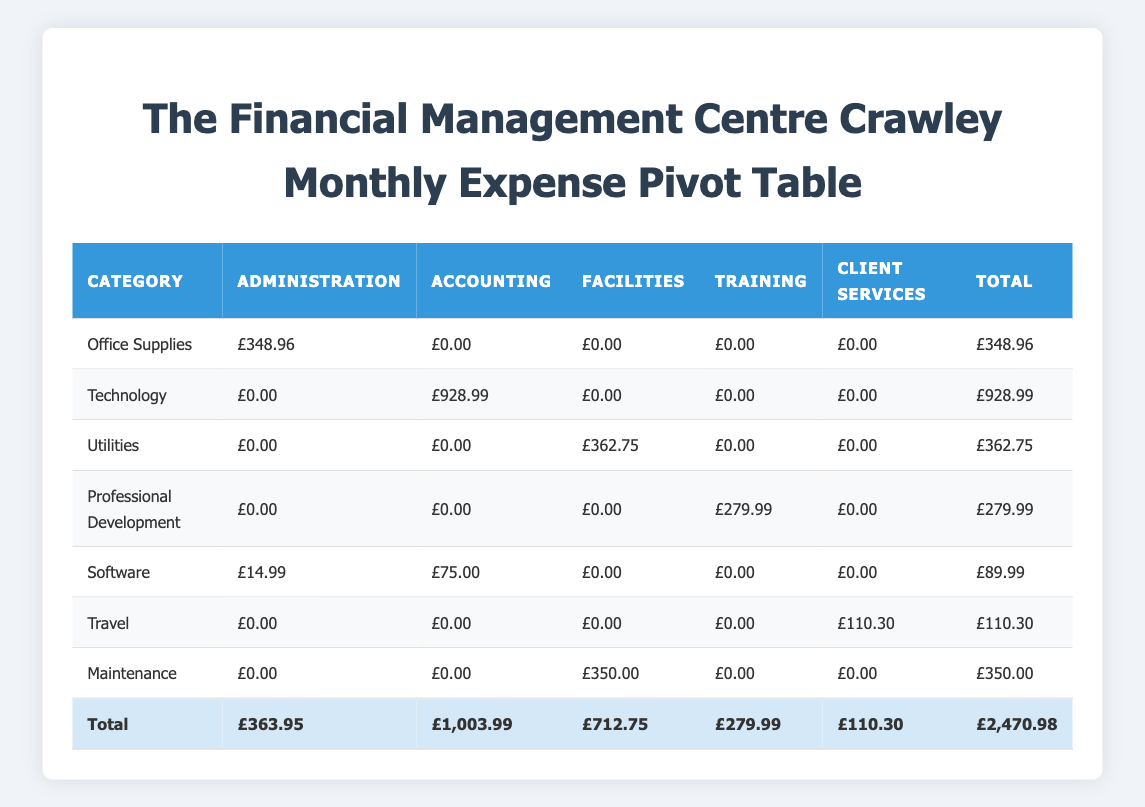What is the total expenditure for the Administration department? By looking at the row for Administration, we can sum its expenses across all categories. The values are £348.96 (Office Supplies), £14.99 (Software), and £0.00 for the other categories. Adding these gives £348.96 + £14.99 = £363.95.
Answer: £363.95 Which department has the highest total expenditure? To find the department with the highest total, we need to look at the total column at the bottom of each department's column. The values are: Administration £363.95, Accounting £1,003.99, Facilities £712.75, Training £279.99, Client Services £110.30. The highest value is £1,003.99 for the Accounting department.
Answer: Accounting What is the total amount spent on Professional Development? We examine the Professional Development row, which has a total of £279.99 for the Training department combined with £0.00 for the others, giving us the total amount spent on this category.
Answer: £279.99 Is there any expenditure listed under the category of Travel for the Administration department? Checking the Travel row, we see the amount listed for the Administration department is £0.00, indicating no expenses were incurred. Hence, the answer is No.
Answer: No What is the difference between the total expenditures of the Accounting department and the Client Services department? We take the total from the Accounting department £1,003.99 and subtract the total from the Client Services department £110.30. The difference is £1,003.99 - £110.30 = £893.69.
Answer: £893.69 What is the average expenditure per category across all departments? To find the average, we first sum up the total expenditures for all categories: £348.96 + £928.99 + £362.75 + £279.99 + £89.99 + £110.30 = £2,120.98. There are 6 categories listed, so we divide the total by 6, giving us £2,120.98 / 6 = £353.50.
Answer: £353.50 Are there any categories that have a total expenditure of more than £400? From the total expenditures of each category: Office Supplies £348.96, Technology £928.99, Utilities £362.75, Professional Development £279.99, Software £89.99, Travel £110.30, Maintenance £350.00. Only the Technology category has total expenditure over £400. Hence, the answer is Yes.
Answer: Yes Which categories have expenditures listed for the Facilities department? Checking the Facilities department column, the categories with expenditures are Utilities (£362.75) and Maintenance (£350.00). Therefore, the categories with expenditures listed are Utilities and Maintenance.
Answer: Utilities and Maintenance 